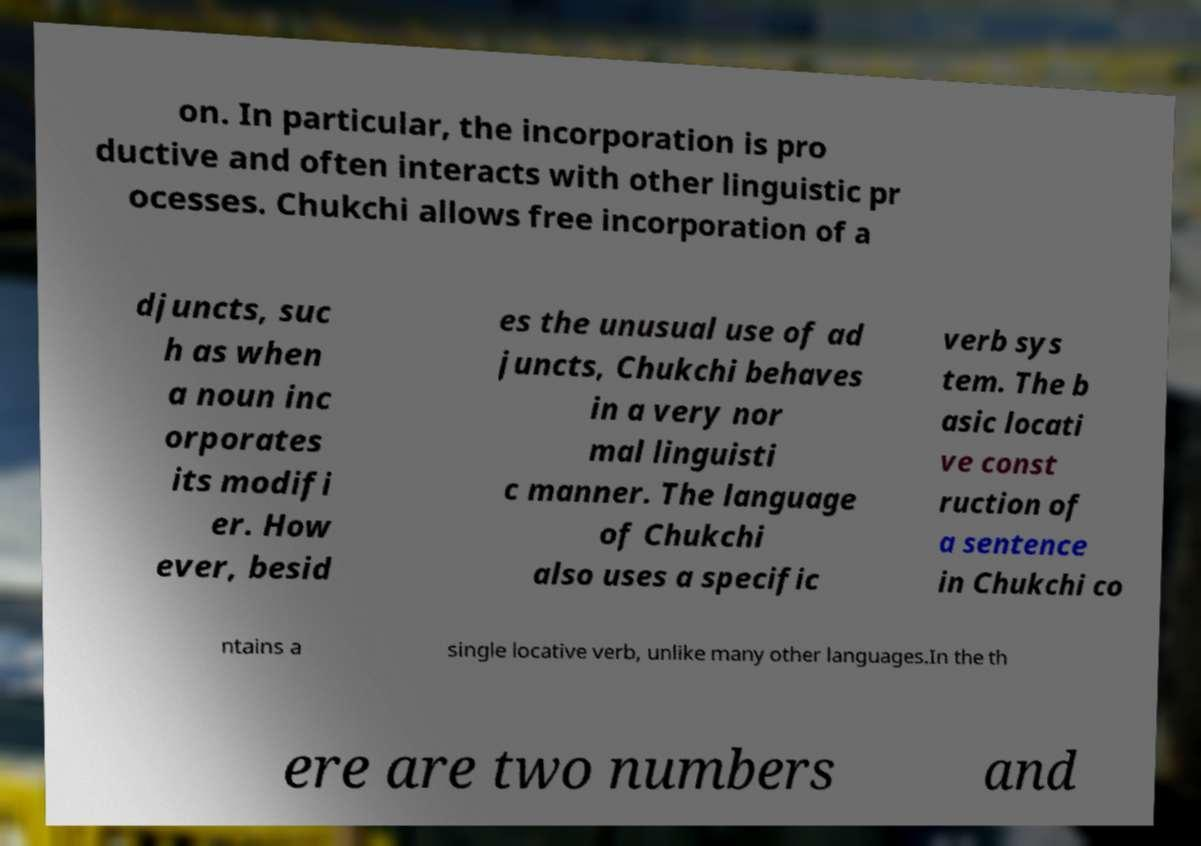For documentation purposes, I need the text within this image transcribed. Could you provide that? on. In particular, the incorporation is pro ductive and often interacts with other linguistic pr ocesses. Chukchi allows free incorporation of a djuncts, suc h as when a noun inc orporates its modifi er. How ever, besid es the unusual use of ad juncts, Chukchi behaves in a very nor mal linguisti c manner. The language of Chukchi also uses a specific verb sys tem. The b asic locati ve const ruction of a sentence in Chukchi co ntains a single locative verb, unlike many other languages.In the th ere are two numbers and 